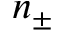Convert formula to latex. <formula><loc_0><loc_0><loc_500><loc_500>n _ { \pm }</formula> 